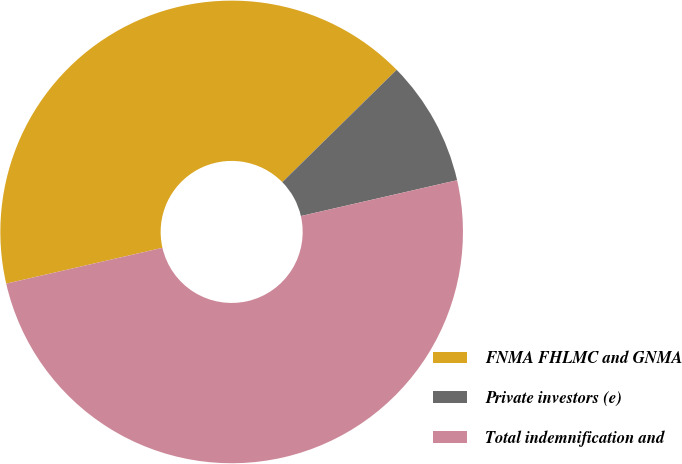Convert chart to OTSL. <chart><loc_0><loc_0><loc_500><loc_500><pie_chart><fcel>FNMA FHLMC and GNMA<fcel>Private investors (e)<fcel>Total indemnification and<nl><fcel>41.23%<fcel>8.77%<fcel>50.0%<nl></chart> 